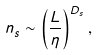Convert formula to latex. <formula><loc_0><loc_0><loc_500><loc_500>n _ { s } \sim \left ( { \frac { L } { \eta } } \right ) ^ { D _ { s } } ,</formula> 